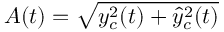<formula> <loc_0><loc_0><loc_500><loc_500>A ( t ) = \sqrt { y _ { c } ^ { 2 } ( t ) + \hat { y } _ { c } ^ { 2 } ( t ) }</formula> 